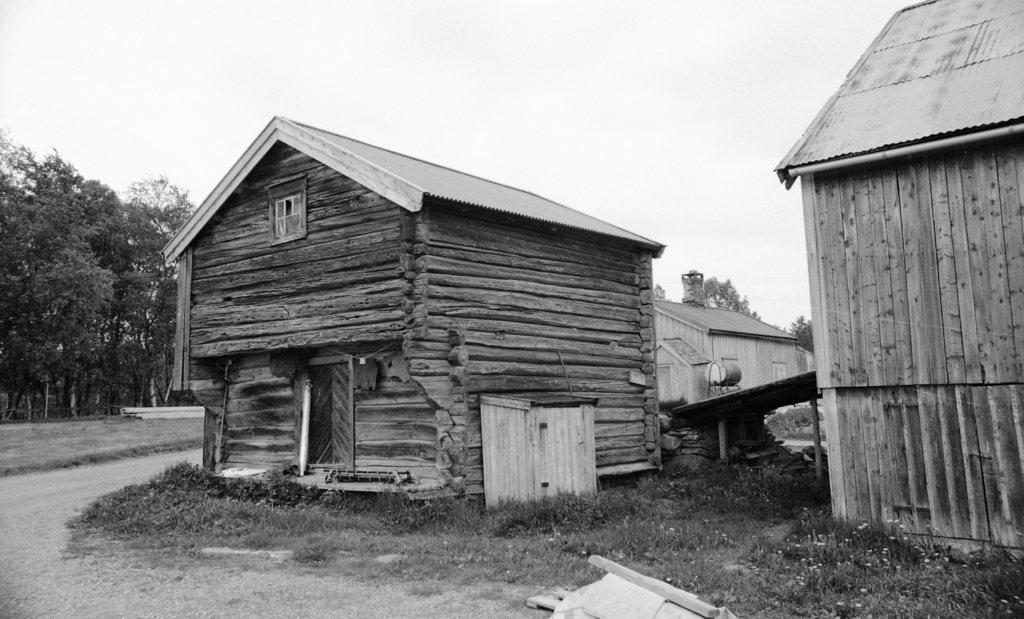How would you summarize this image in a sentence or two? This is a black and white image. In this picture we can see the houses, roofs, trees, grass and ground. At the bottom of the image we can see the ground. At the top of the image we can see the sky. In the bottom right corner we can see the flowers. 